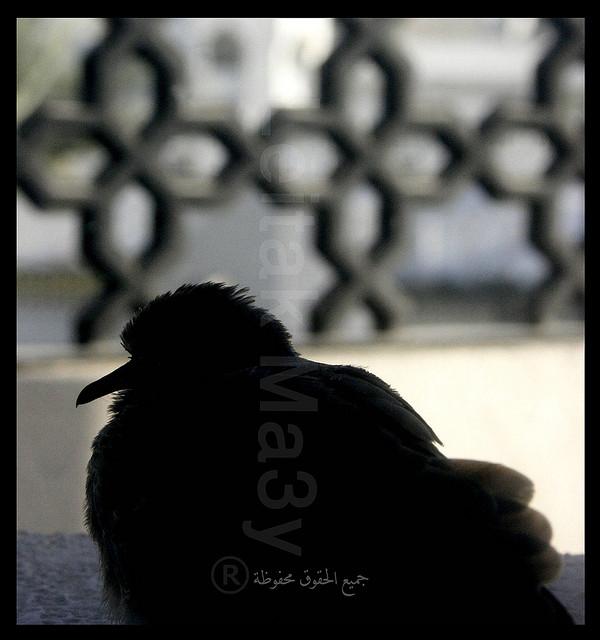Is this photo indoors?
Keep it brief. No. What is in front of the bird?
Quick response, please. Fence. What textile do these animals play a part in producing?
Give a very brief answer. Feather. What shape is in the background?
Keep it brief. Cross. What color is the bird?
Short answer required. Black. What kind of bird is this?
Concise answer only. Pigeon. 